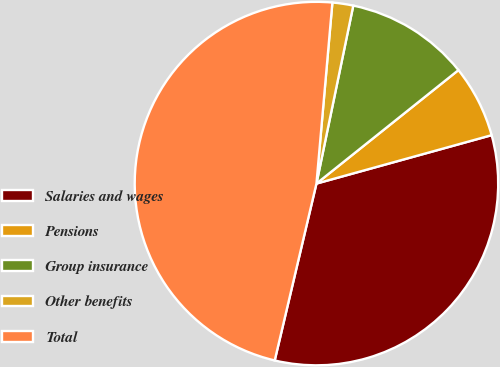<chart> <loc_0><loc_0><loc_500><loc_500><pie_chart><fcel>Salaries and wages<fcel>Pensions<fcel>Group insurance<fcel>Other benefits<fcel>Total<nl><fcel>32.98%<fcel>6.44%<fcel>11.02%<fcel>1.85%<fcel>47.71%<nl></chart> 